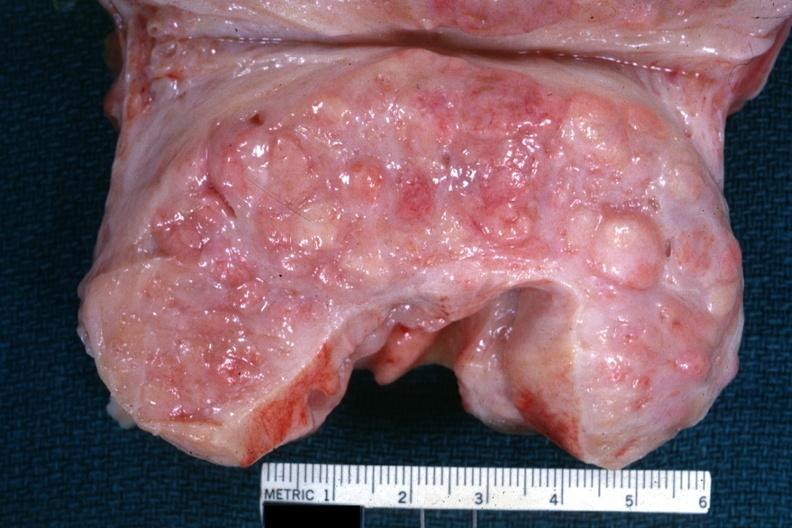what is present?
Answer the question using a single word or phrase. Hyperplasia 